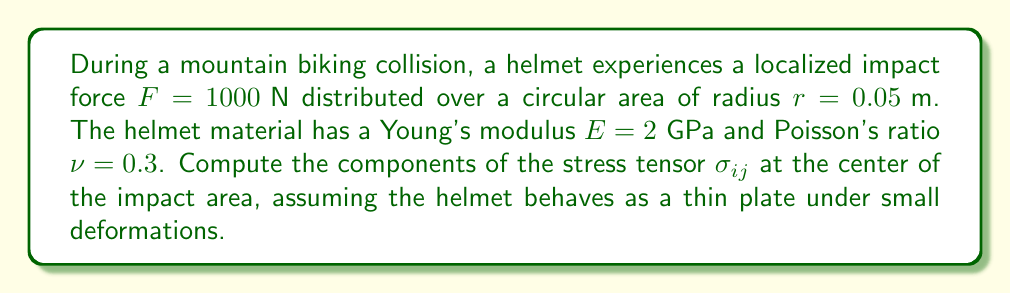Can you answer this question? To solve this problem, we'll follow these steps:

1) First, we need to calculate the pressure $P$ applied to the impact area:
   $$P = \frac{F}{\pi r^2} = \frac{1000}{\pi (0.05)^2} \approx 127,324 \text{ Pa}$$

2) For a thin plate under small deformations, we can use the plane stress approximation. The stress tensor in cylindrical coordinates $(r, \theta, z)$ is:

   $$\sigma_{rr} = \sigma_{\theta\theta} = \frac{P}{2}\left(1 - \frac{r^2}{a^2}\right)$$
   $$\sigma_{zz} = -P$$
   $$\sigma_{r\theta} = \sigma_{rz} = \sigma_{\theta z} = 0$$

   where $a$ is the radius of the circular impact area.

3) At the center of the impact $(r = 0)$, we have:

   $$\sigma_{rr} = \sigma_{\theta\theta} = \frac{P}{2} = \frac{127,324}{2} \approx 63,662 \text{ Pa}$$
   $$\sigma_{zz} = -P = -127,324 \text{ Pa}$$

4) To convert from cylindrical to Cartesian coordinates, we use the transformation:

   $$\sigma_{xx} = \sigma_{yy} = \sigma_{rr} = \sigma_{\theta\theta}$$
   $$\sigma_{zz} = \sigma_{zz}$$
   $$\sigma_{xy} = \sigma_{xz} = \sigma_{yz} = 0$$

5) Therefore, the stress tensor in Cartesian coordinates at the center of the impact is:

   $$\sigma_{ij} = \begin{pmatrix}
   63,662 & 0 & 0 \\
   0 & 63,662 & 0 \\
   0 & 0 & -127,324
   \end{pmatrix} \text{ Pa}$$
Answer: $$\sigma_{ij} = \begin{pmatrix}
63,662 & 0 & 0 \\
0 & 63,662 & 0 \\
0 & 0 & -127,324
\end{pmatrix} \text{ Pa}$$ 